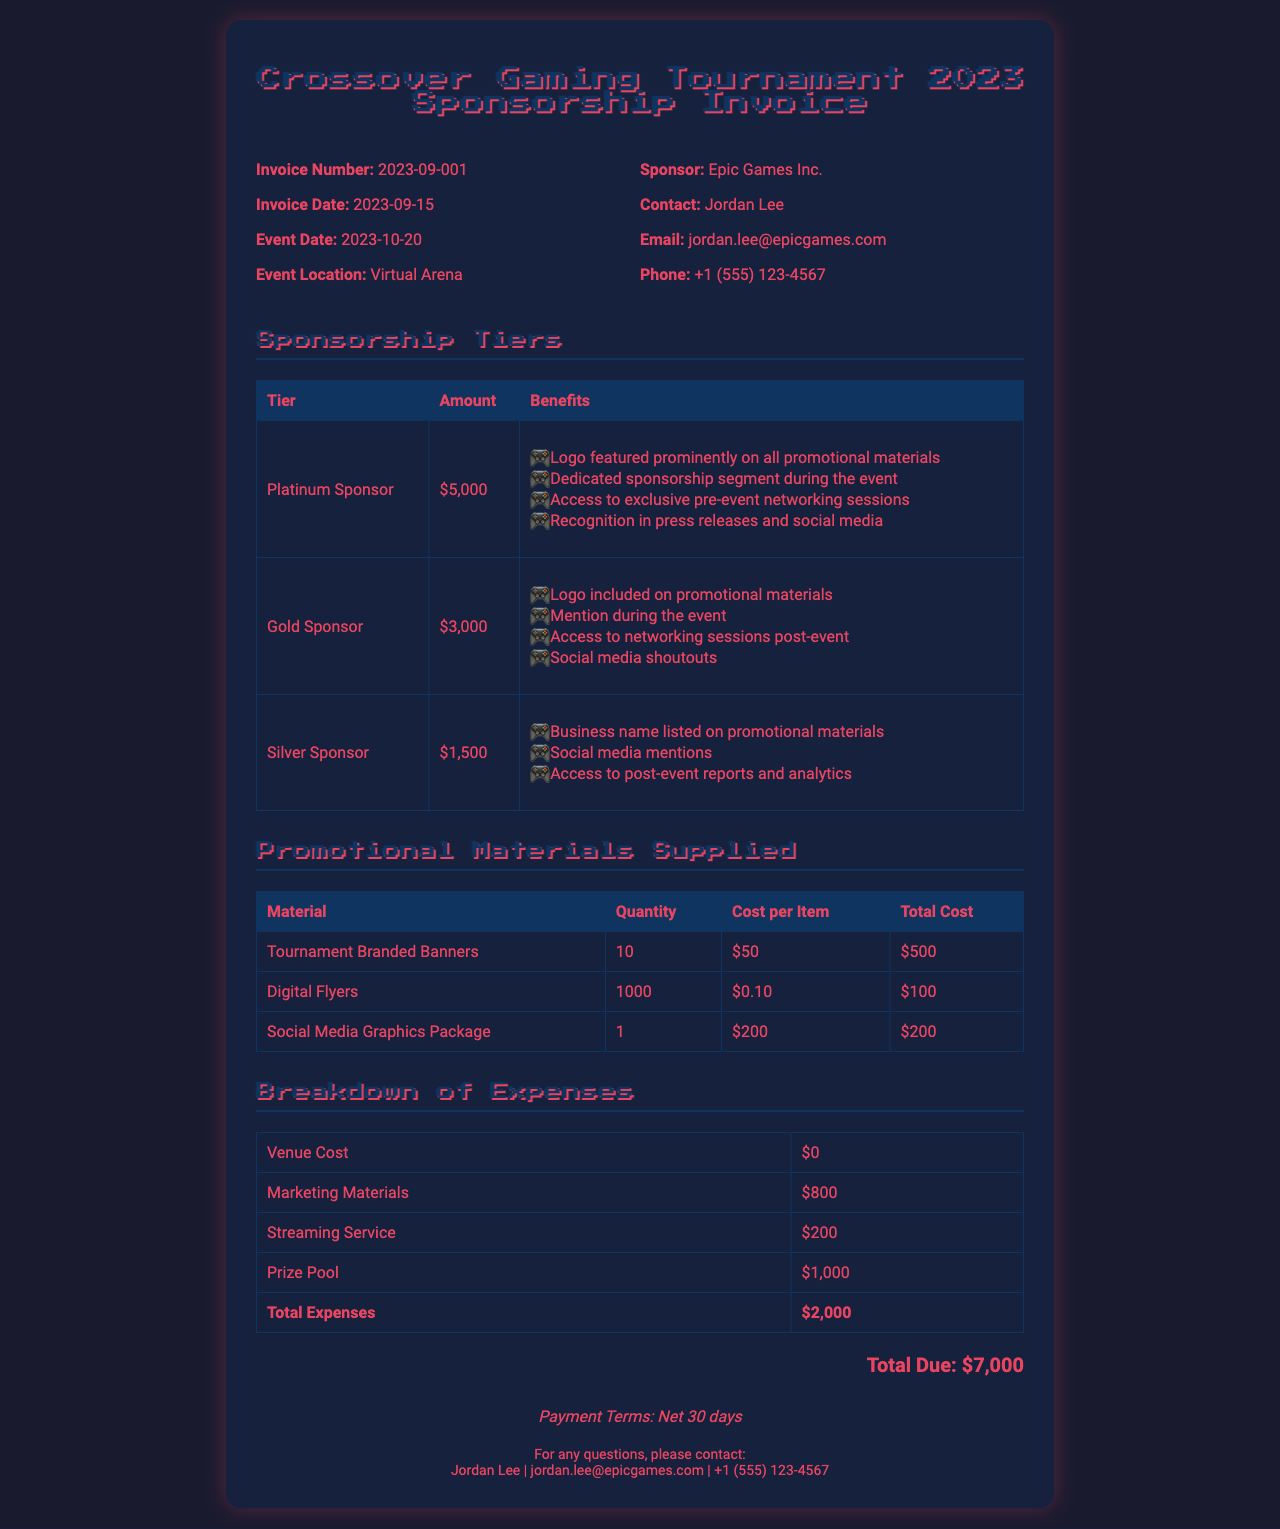What is the total due amount? The total due amount is indicated at the bottom of the invoice and summarizes all expenses and sponsorship fees.
Answer: $7,000 What is the invoice number? The invoice number is used for record-keeping and is displayed in the invoice details section.
Answer: 2023-09-001 Who is the sponsor contact? The sponsor contact's name is mentioned in the sponsor details section of the invoice.
Answer: Jordan Lee What tier amount corresponds to a Gold Sponsor? The tier specific to Gold Sponsor includes a set amount for its sponsorship.
Answer: $3,000 How many Digital Flyers were supplied? The quantity supplied is clearly mentioned in the promotional materials section of the invoice.
Answer: 1000 What are the total expenses listed in the breakdown? The total expenses summarize various costs and are found towards the end of the expense breakdown table.
Answer: $2,000 What date is the event scheduled? The event date provides detail about when the event will take place and is indicated in the invoice details section.
Answer: 2023-10-20 What is the payment term specified? The payment terms are outlined to inform sponsors when payments should be made.
Answer: Net 30 days What types of promotional materials were provided? The promotional materials section describes the types of marketing items distributed during the event.
Answer: Tournament Branded Banners, Digital Flyers, Social Media Graphics Package 